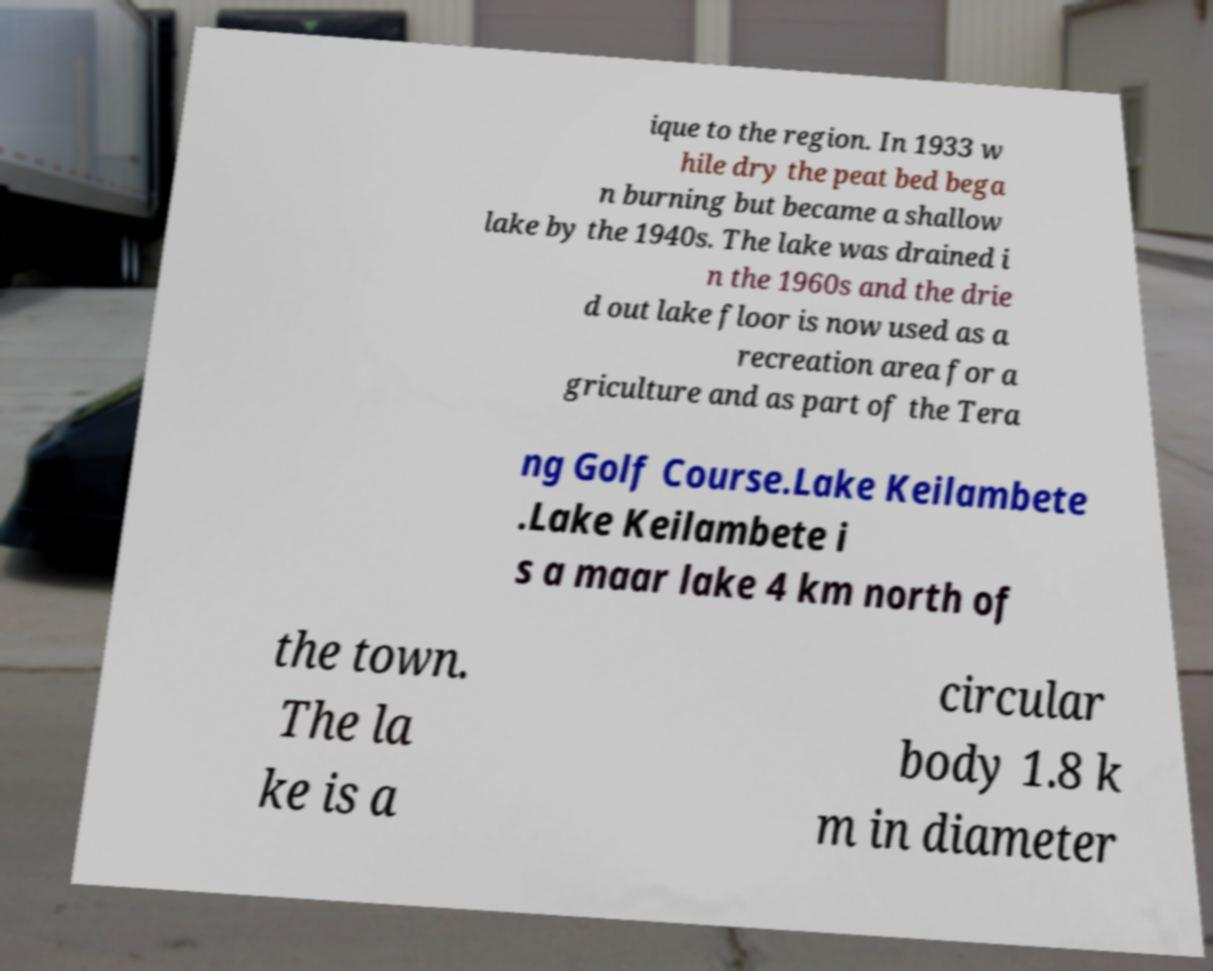There's text embedded in this image that I need extracted. Can you transcribe it verbatim? ique to the region. In 1933 w hile dry the peat bed bega n burning but became a shallow lake by the 1940s. The lake was drained i n the 1960s and the drie d out lake floor is now used as a recreation area for a griculture and as part of the Tera ng Golf Course.Lake Keilambete .Lake Keilambete i s a maar lake 4 km north of the town. The la ke is a circular body 1.8 k m in diameter 